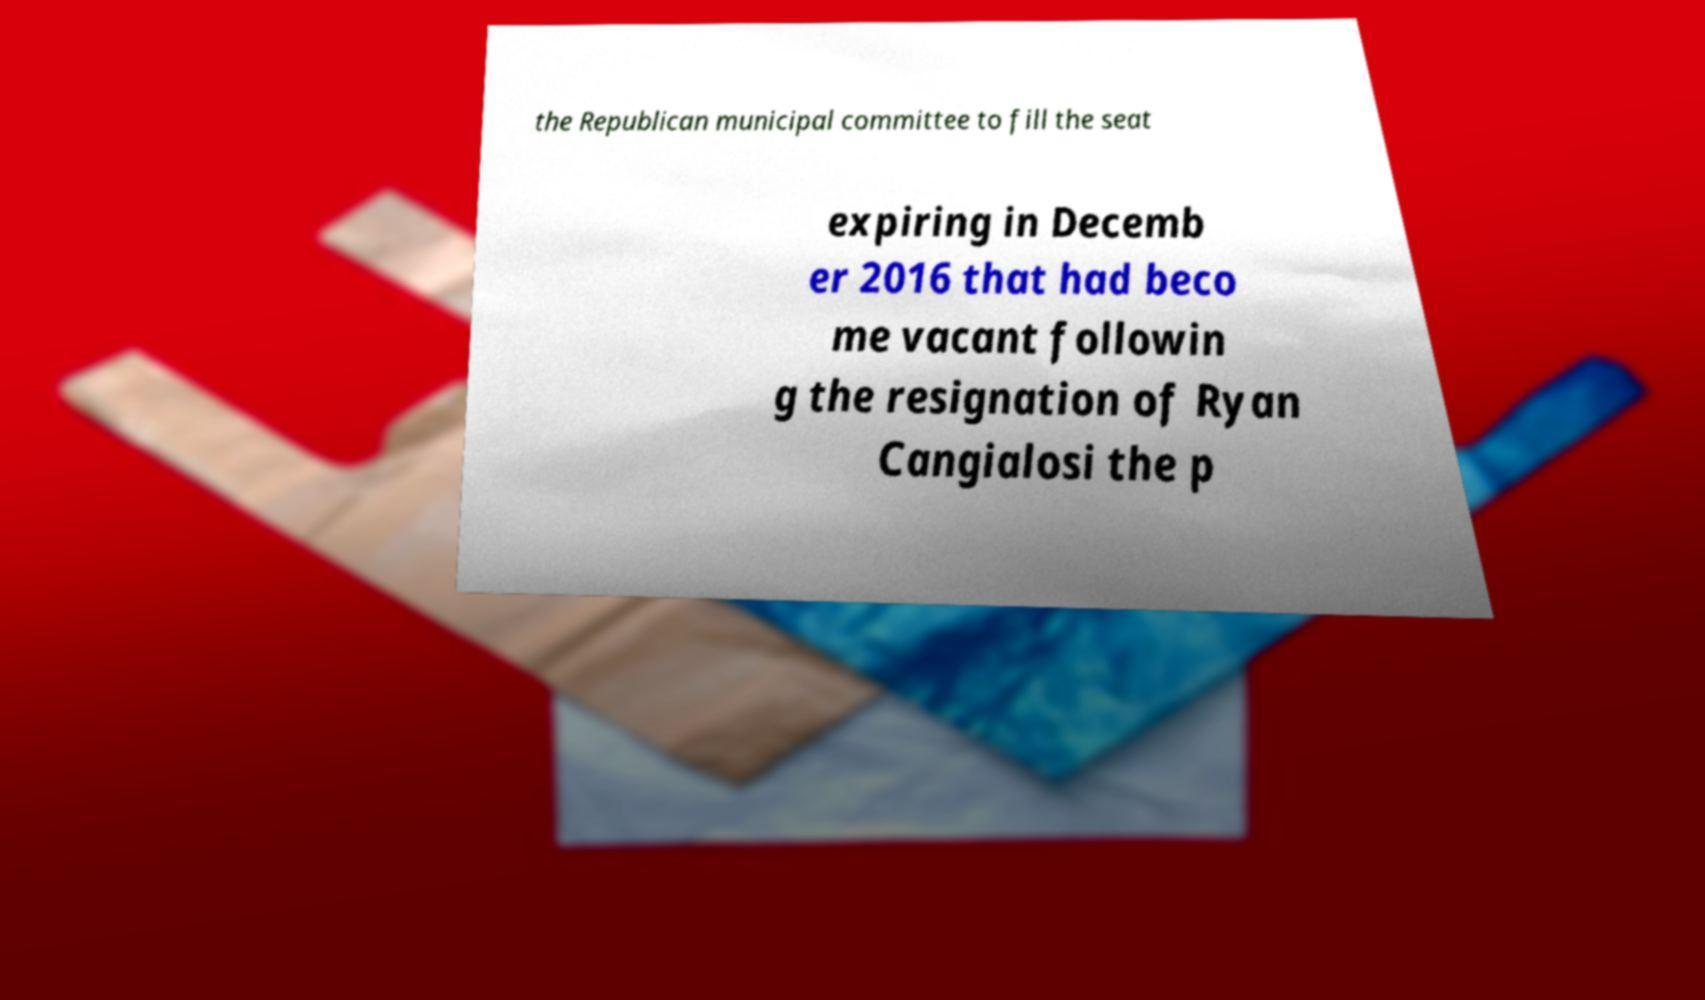For documentation purposes, I need the text within this image transcribed. Could you provide that? the Republican municipal committee to fill the seat expiring in Decemb er 2016 that had beco me vacant followin g the resignation of Ryan Cangialosi the p 